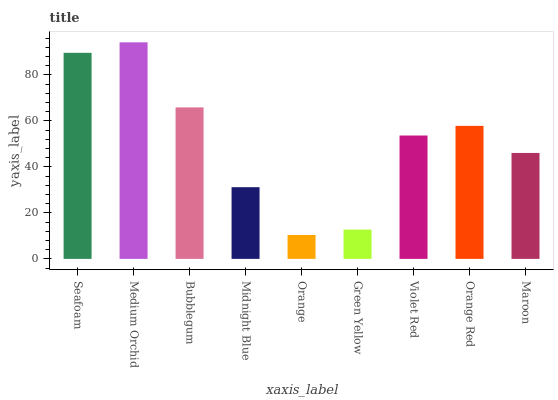Is Orange the minimum?
Answer yes or no. Yes. Is Medium Orchid the maximum?
Answer yes or no. Yes. Is Bubblegum the minimum?
Answer yes or no. No. Is Bubblegum the maximum?
Answer yes or no. No. Is Medium Orchid greater than Bubblegum?
Answer yes or no. Yes. Is Bubblegum less than Medium Orchid?
Answer yes or no. Yes. Is Bubblegum greater than Medium Orchid?
Answer yes or no. No. Is Medium Orchid less than Bubblegum?
Answer yes or no. No. Is Violet Red the high median?
Answer yes or no. Yes. Is Violet Red the low median?
Answer yes or no. Yes. Is Green Yellow the high median?
Answer yes or no. No. Is Bubblegum the low median?
Answer yes or no. No. 